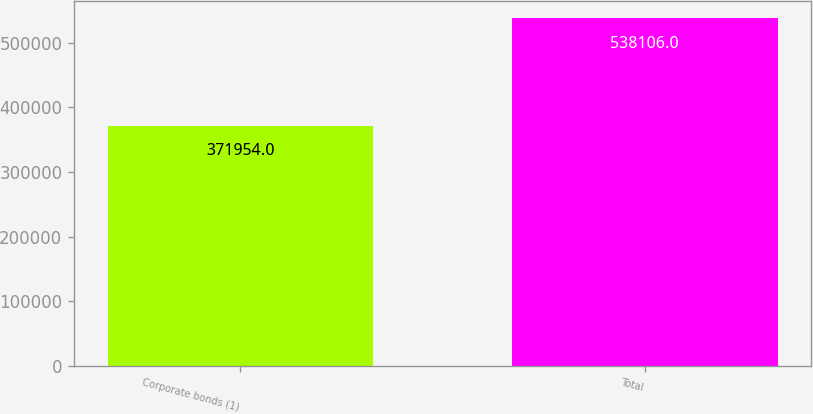Convert chart to OTSL. <chart><loc_0><loc_0><loc_500><loc_500><bar_chart><fcel>Corporate bonds (1)<fcel>Total<nl><fcel>371954<fcel>538106<nl></chart> 